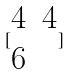<formula> <loc_0><loc_0><loc_500><loc_500>[ \begin{matrix} 4 & 4 \\ 6 \end{matrix} ]</formula> 